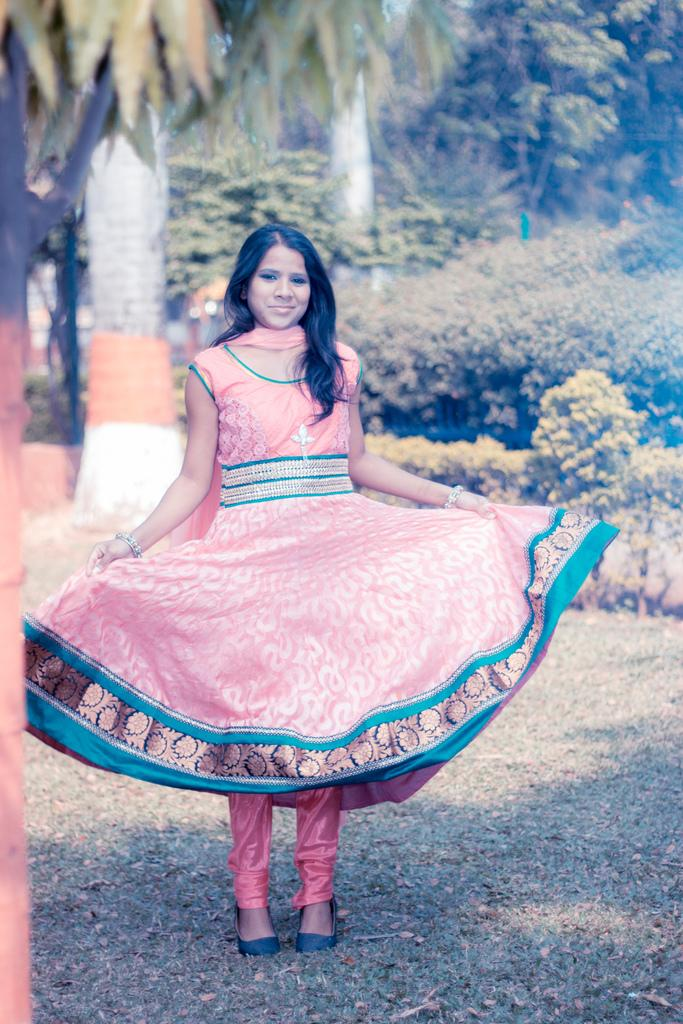Who is present in the image? There is a woman in the image. What is the woman doing in the image? The woman is standing and holding her dress. What type of vegetation can be seen in the image? There are plants and trees visible in the image. What type of agreement is the woman signing in the image? There is no agreement or document present in the image for the woman to sign. 